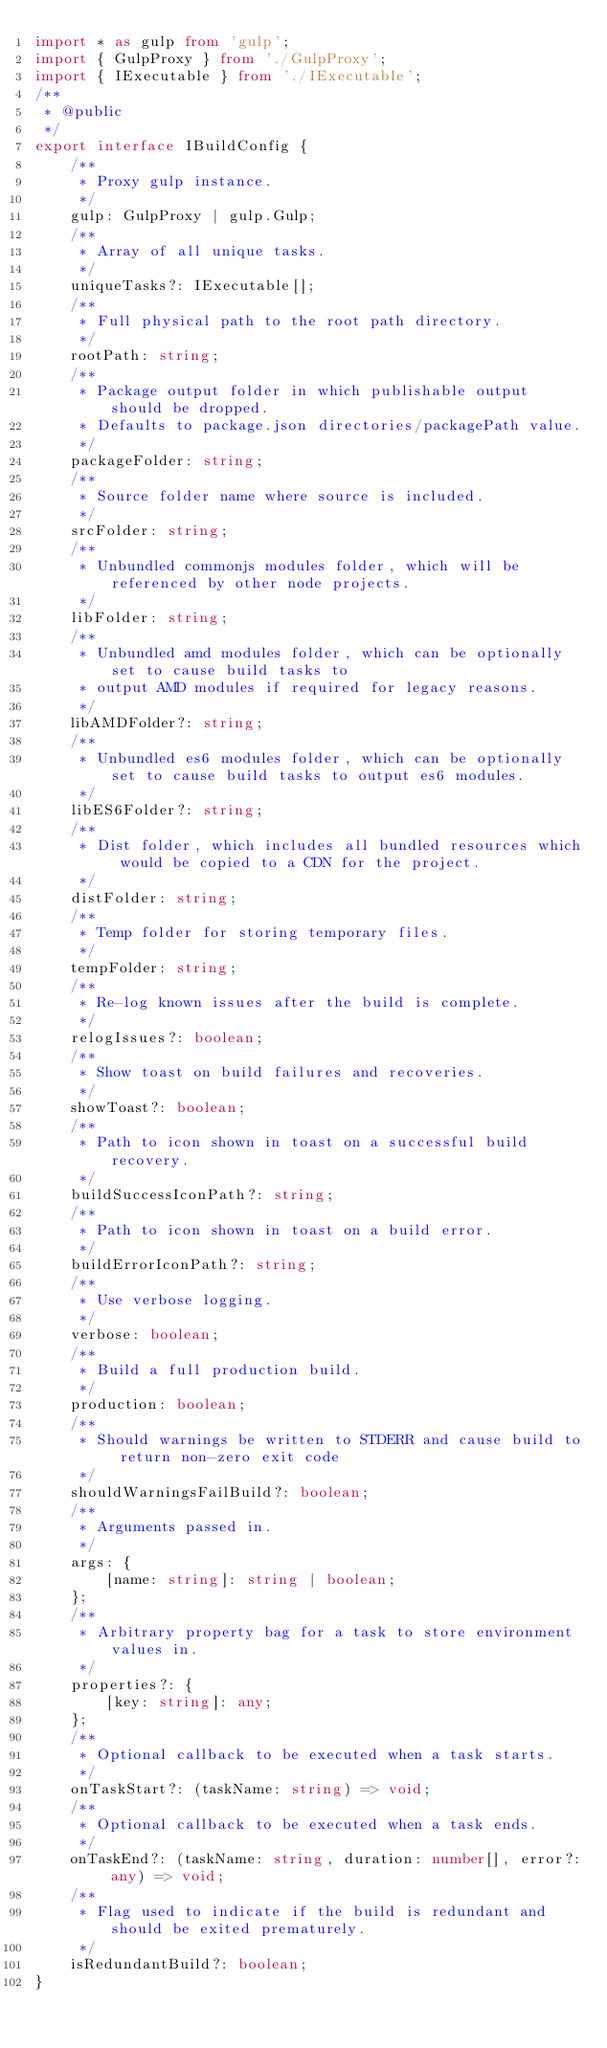<code> <loc_0><loc_0><loc_500><loc_500><_TypeScript_>import * as gulp from 'gulp';
import { GulpProxy } from './GulpProxy';
import { IExecutable } from './IExecutable';
/**
 * @public
 */
export interface IBuildConfig {
    /**
     * Proxy gulp instance.
     */
    gulp: GulpProxy | gulp.Gulp;
    /**
     * Array of all unique tasks.
     */
    uniqueTasks?: IExecutable[];
    /**
     * Full physical path to the root path directory.
     */
    rootPath: string;
    /**
     * Package output folder in which publishable output should be dropped.
     * Defaults to package.json directories/packagePath value.
     */
    packageFolder: string;
    /**
     * Source folder name where source is included.
     */
    srcFolder: string;
    /**
     * Unbundled commonjs modules folder, which will be referenced by other node projects.
     */
    libFolder: string;
    /**
     * Unbundled amd modules folder, which can be optionally set to cause build tasks to
     * output AMD modules if required for legacy reasons.
     */
    libAMDFolder?: string;
    /**
     * Unbundled es6 modules folder, which can be optionally set to cause build tasks to output es6 modules.
     */
    libES6Folder?: string;
    /**
     * Dist folder, which includes all bundled resources which would be copied to a CDN for the project.
     */
    distFolder: string;
    /**
     * Temp folder for storing temporary files.
     */
    tempFolder: string;
    /**
     * Re-log known issues after the build is complete.
     */
    relogIssues?: boolean;
    /**
     * Show toast on build failures and recoveries.
     */
    showToast?: boolean;
    /**
     * Path to icon shown in toast on a successful build recovery.
     */
    buildSuccessIconPath?: string;
    /**
     * Path to icon shown in toast on a build error.
     */
    buildErrorIconPath?: string;
    /**
     * Use verbose logging.
     */
    verbose: boolean;
    /**
     * Build a full production build.
     */
    production: boolean;
    /**
     * Should warnings be written to STDERR and cause build to return non-zero exit code
     */
    shouldWarningsFailBuild?: boolean;
    /**
     * Arguments passed in.
     */
    args: {
        [name: string]: string | boolean;
    };
    /**
     * Arbitrary property bag for a task to store environment values in.
     */
    properties?: {
        [key: string]: any;
    };
    /**
     * Optional callback to be executed when a task starts.
     */
    onTaskStart?: (taskName: string) => void;
    /**
     * Optional callback to be executed when a task ends.
     */
    onTaskEnd?: (taskName: string, duration: number[], error?: any) => void;
    /**
     * Flag used to indicate if the build is redundant and should be exited prematurely.
     */
    isRedundantBuild?: boolean;
}
</code> 